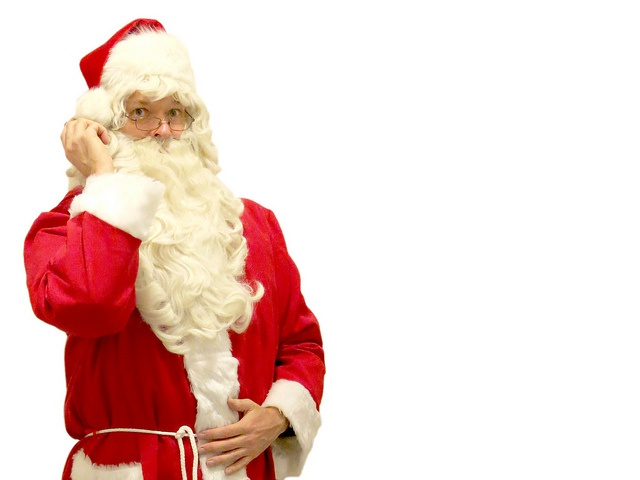Describe the objects in this image and their specific colors. I can see people in white, maroon, beige, tan, and brown tones in this image. 